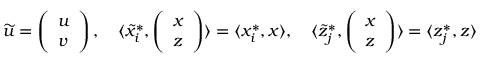Convert formula to latex. <formula><loc_0><loc_0><loc_500><loc_500>\widetilde { u } = \left ( \begin{array} { l } { u } \\ { v } \end{array} \right ) , \quad \langle \widetilde { x } _ { i } ^ { * } , \left ( \begin{array} { l } { x } \\ { z } \end{array} \right ) \rangle = \langle x _ { i } ^ { * } , x \rangle , \quad \langle \widetilde { z } _ { j } ^ { * } , \left ( \begin{array} { l } { x } \\ { z } \end{array} \right ) \rangle = \langle z _ { j } ^ { * } , z \rangle</formula> 